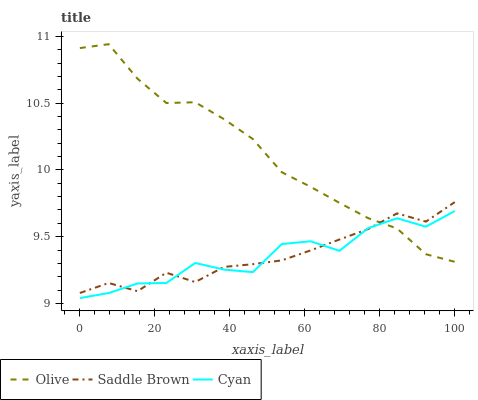Does Cyan have the minimum area under the curve?
Answer yes or no. Yes. Does Olive have the maximum area under the curve?
Answer yes or no. Yes. Does Saddle Brown have the minimum area under the curve?
Answer yes or no. No. Does Saddle Brown have the maximum area under the curve?
Answer yes or no. No. Is Olive the smoothest?
Answer yes or no. Yes. Is Cyan the roughest?
Answer yes or no. Yes. Is Saddle Brown the smoothest?
Answer yes or no. No. Is Saddle Brown the roughest?
Answer yes or no. No. Does Cyan have the lowest value?
Answer yes or no. Yes. Does Saddle Brown have the lowest value?
Answer yes or no. No. Does Olive have the highest value?
Answer yes or no. Yes. Does Saddle Brown have the highest value?
Answer yes or no. No. Does Cyan intersect Olive?
Answer yes or no. Yes. Is Cyan less than Olive?
Answer yes or no. No. Is Cyan greater than Olive?
Answer yes or no. No. 